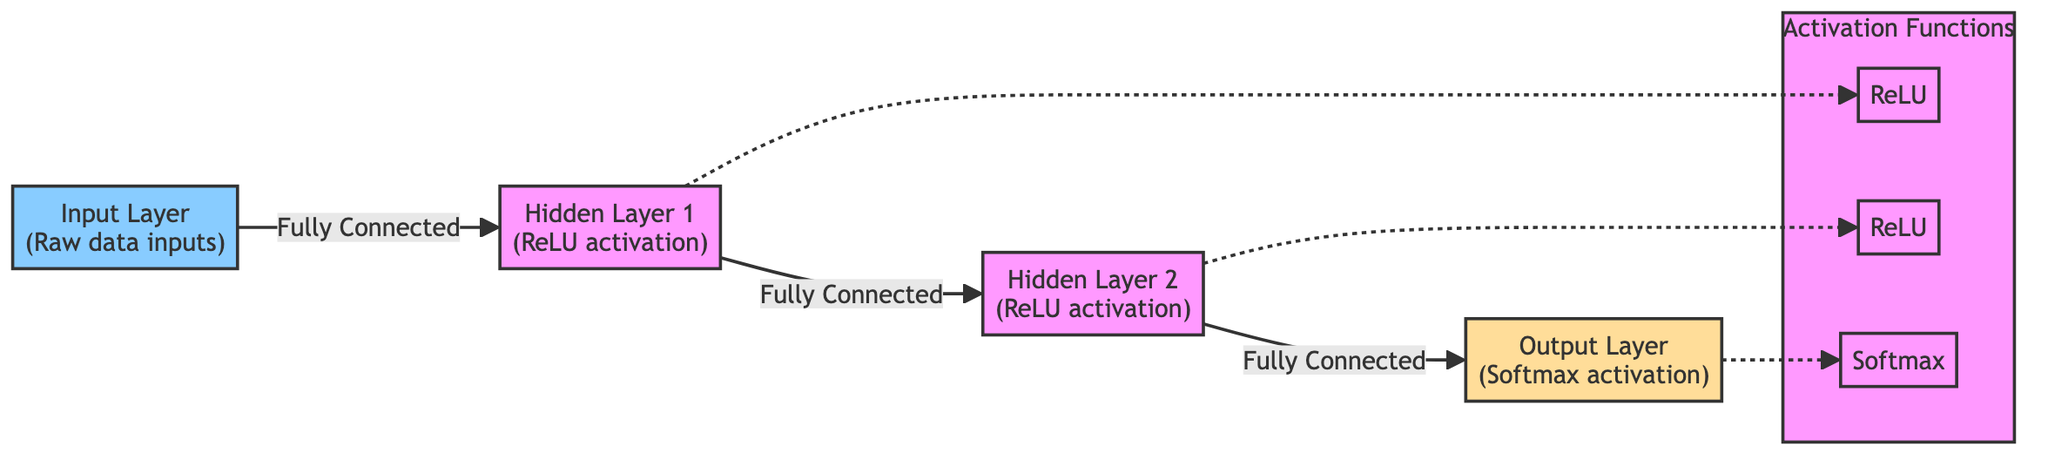What is the activation function used in the first hidden layer? The diagram indicates that the first hidden layer uses the ReLU activation function, which is specifically labeled next to "Hidden Layer 1".
Answer: ReLU How many layers are shown in the diagram? By counting the layers depicted in the diagram, there are three distinct layers: the input layer, the hidden layers, and the output layer.
Answer: Three Which layer employs the Softmax activation function? The diagram explicitly mentions that the output layer utilizes the Softmax activation function, indicated next to "Output Layer".
Answer: Output Layer What type of connections exist between the layers? The diagram illustrates that there are "Fully Connected" relationships between all consecutive layers, meaning every node in one layer connects to every node in the subsequent layer.
Answer: Fully Connected What is the relationship between Hidden Layer 2 and the Softmax activation? The diagram shows that Hidden Layer 2 is connected to the output layer, which in turn uses the Softmax activation function. This implies that output data from Hidden Layer 2 feeds directly into the Softmax function.
Answer: Outputs to Softmax How many activation functions are shown in the diagram? The diagram clearly depicts three activation functions: two ReLU functions (one for each hidden layer) and one Softmax function for the output layer.
Answer: Three What connects Hidden Layer 1 to the next layer? According to the diagram, Hidden Layer 1 is connected to Hidden Layer 2 through a “Fully Connected” pathway, indicating a direct connection between them.
Answer: Fully Connected What distinguishes the output layer from the hidden layers? The output layer is specifically labeled with "Softmax activation", which distinguishes it from the hidden layers that utilize the ReLU activation function.
Answer: Softmax activation What type of layer is the input layer categorized as? The diagram categorizes the input layer as "Input Layer (Raw data inputs)", which indicates it receives the initial data for processing.
Answer: Input Layer 